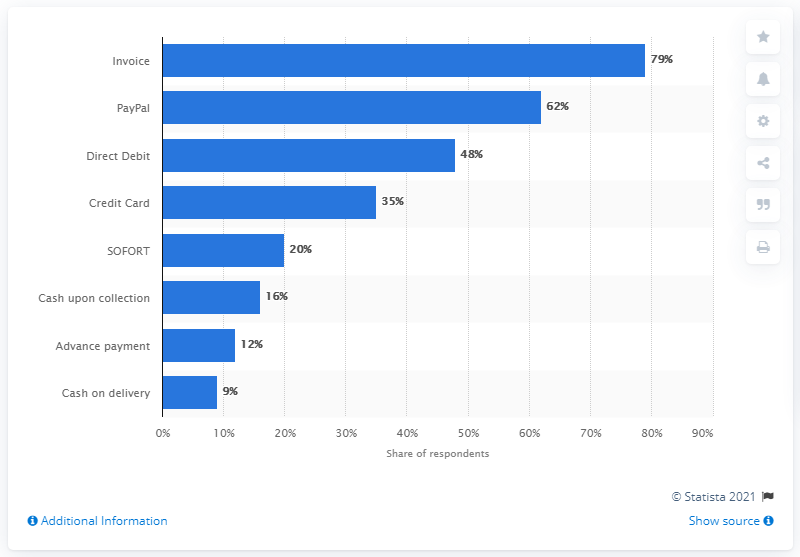Point out several critical features in this image. A large percentage of customers in Germany, 35%, still prefer to make credit card payments. 